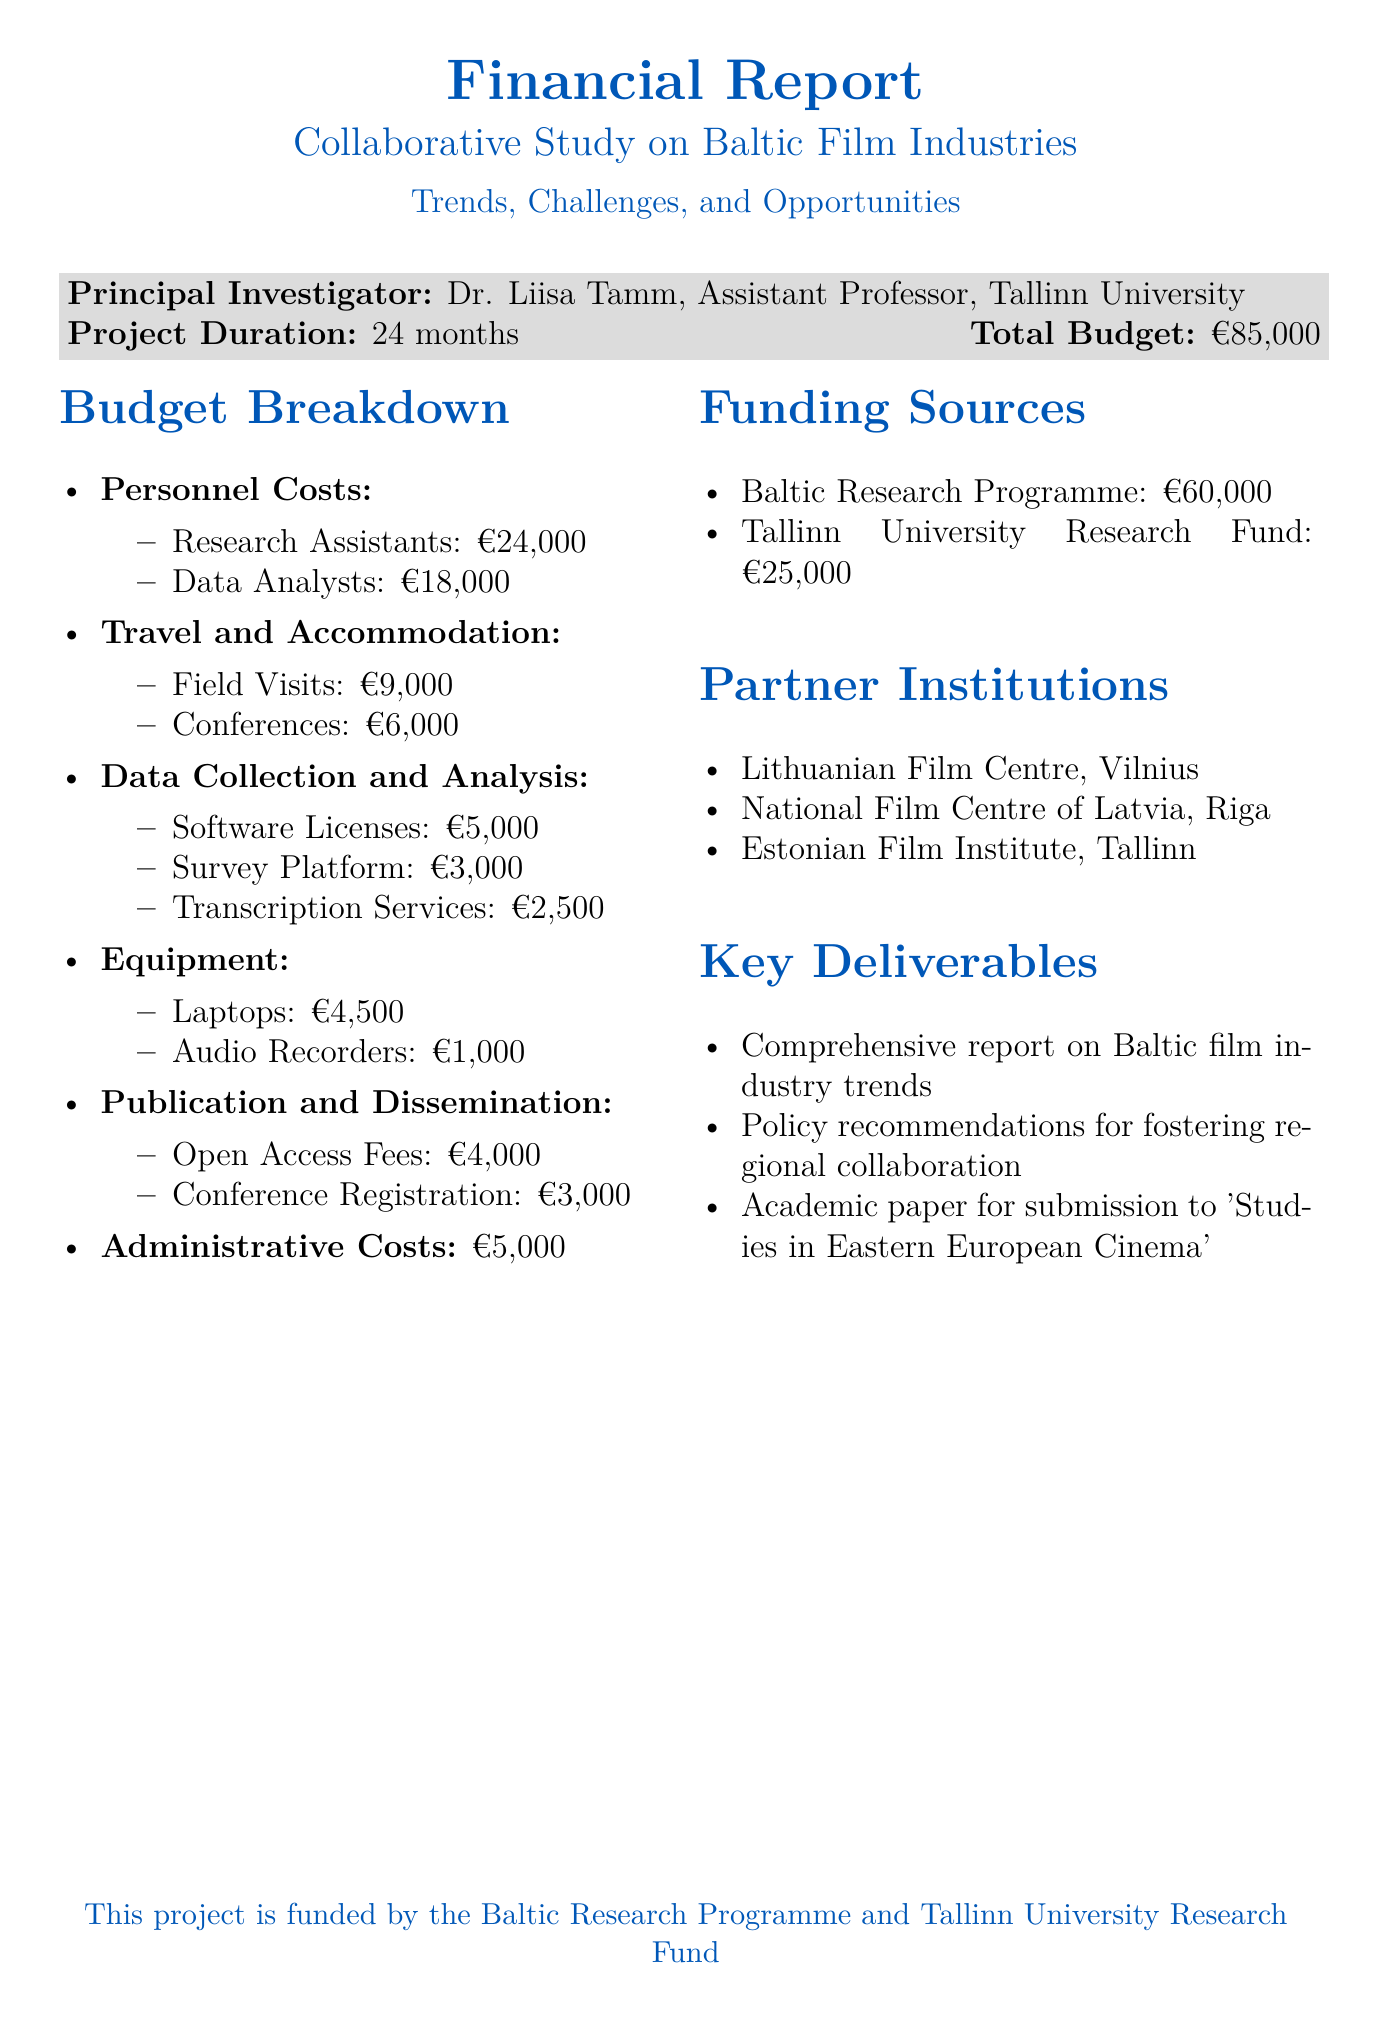what is the project title? The project title is prominently stated at the beginning of the document.
Answer: Collaborative Study on Baltic Film Industries: Trends, Challenges, and Opportunities who is the principal investigator? The principal investigator's name and title are provided in the document's introductory section.
Answer: Dr. Liisa Tamm, Assistant Professor, Tallinn University what is the total budget for the project? The total budget is specified under the project details, clearly indicating the financial scope.
Answer: €85,000 how much is allocated for research assistants? The budget breakdown includes specific amounts allocated for different personnel costs.
Answer: €24,000 what are the two main funding sources listed? The funding sources are listed with their respective amounts, showing where the project funds originate.
Answer: Baltic Research Programme and Tallinn University Research Fund how long is the project duration? The project duration is stated explicitly in the introductory section of the document.
Answer: 24 months what is one of the key deliverables of the project? A list of key deliverables is included, highlighting what the project aims to achieve.
Answer: Comprehensive report on Baltic film industry trends how much is budgeted for field visits? The travel and accommodation section specifies amounts for various expenses related to travel.
Answer: €9,000 how much will be spent on data collection and analysis? This specific section of the budget highlights the investments in data-related activities.
Answer: €10,500 